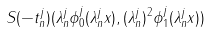<formula> <loc_0><loc_0><loc_500><loc_500>S ( - t _ { n } ^ { j } ) ( \lambda _ { n } ^ { j } \phi _ { 0 } ^ { j } ( \lambda _ { n } ^ { j } x ) , ( \lambda _ { n } ^ { j } ) ^ { 2 } \phi _ { 1 } ^ { j } ( \lambda _ { n } ^ { j } x ) )</formula> 